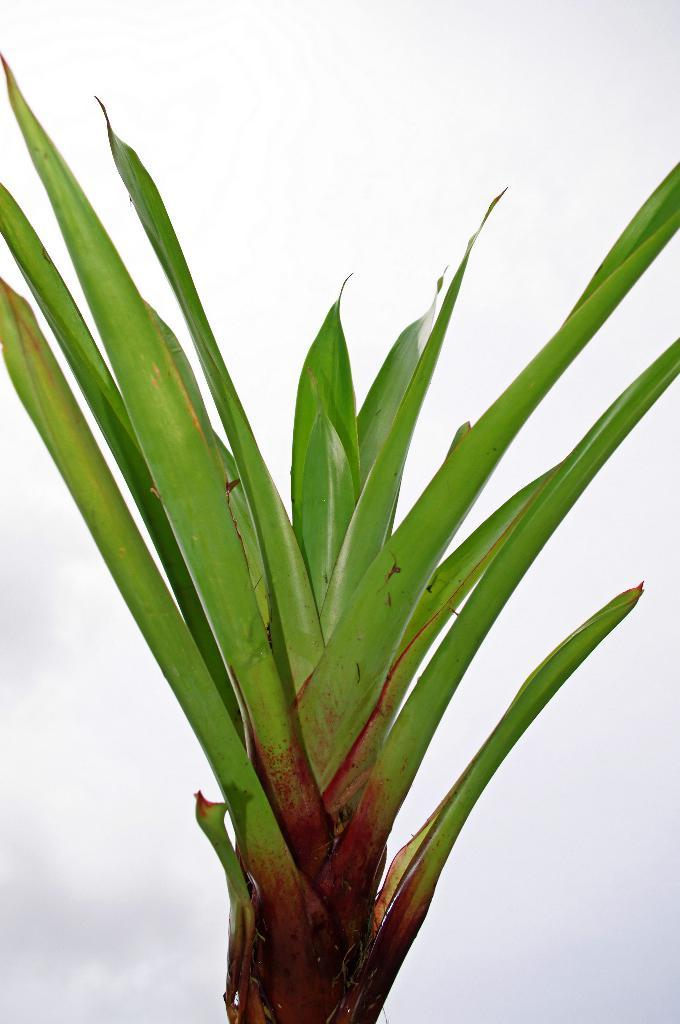What is present in the image? There is a plant in the image. What can be seen in the background of the image? The sky is visible in the background of the image. What is the condition of the sky in the image? Clouds are present in the sky. What is the temperature of the plant in the image? The temperature of the plant cannot be determined from the image, as temperature is not a visible characteristic of the plant in the image. 